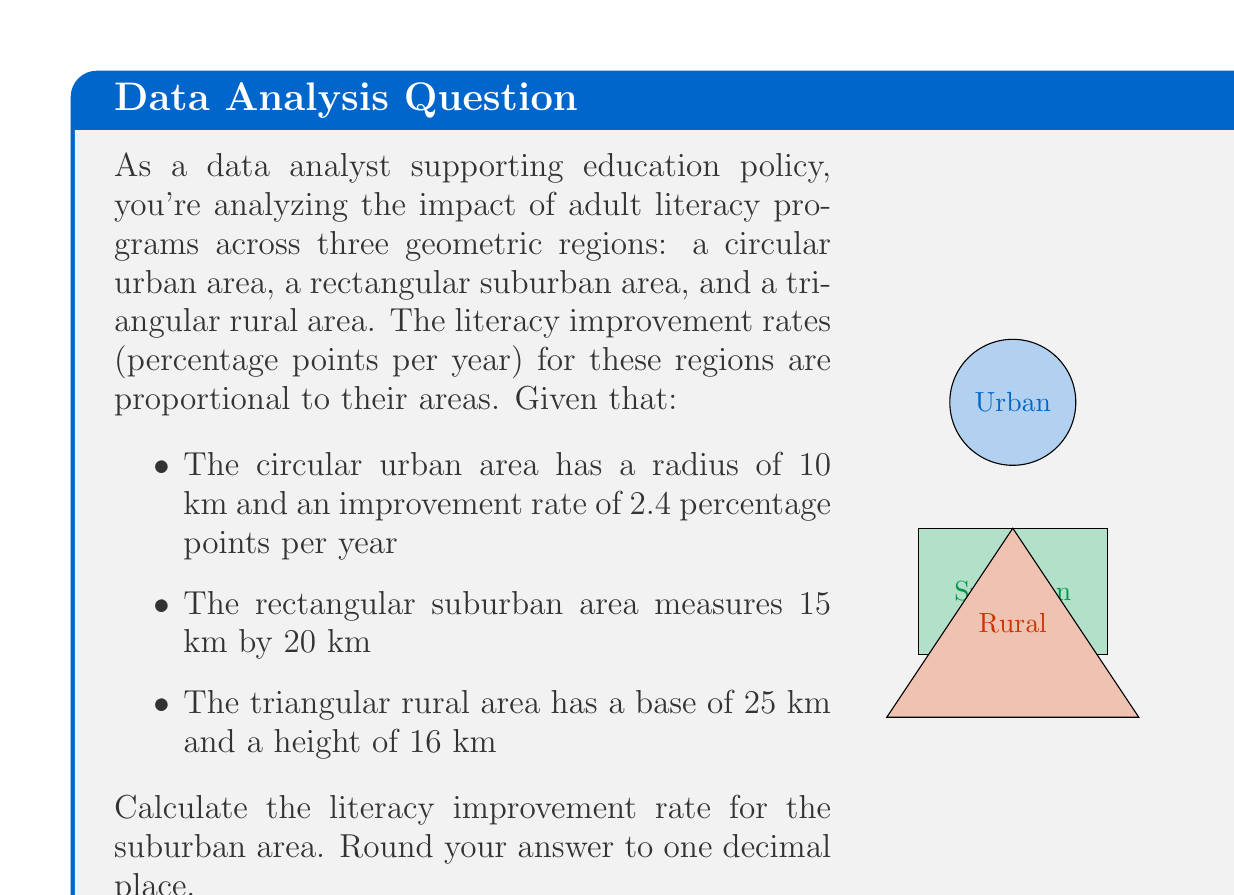Teach me how to tackle this problem. To solve this problem, we need to:
1. Calculate the areas of all three regions
2. Set up a proportion to find the improvement rate for the suburban area

Step 1: Calculate areas

Urban (circular) area:
$$ A_u = \pi r^2 = \pi \cdot 10^2 = 100\pi \approx 314.16 \text{ km}^2 $$

Suburban (rectangular) area:
$$ A_s = l \cdot w = 15 \cdot 20 = 300 \text{ km}^2 $$

Rural (triangular) area:
$$ A_r = \frac{1}{2} \cdot b \cdot h = \frac{1}{2} \cdot 25 \cdot 16 = 200 \text{ km}^2 $$

Step 2: Set up proportion

Let $x$ be the improvement rate for the suburban area. The proportion is:

$$ \frac{\text{Urban rate}}{\text{Urban area}} = \frac{\text{Suburban rate}}{\text{Suburban area}} $$

$$ \frac{2.4}{100\pi} = \frac{x}{300} $$

Step 3: Solve for $x$

$$ x = \frac{2.4 \cdot 300}{100\pi} \approx 2.291549 $$

Rounding to one decimal place: 2.3 percentage points per year.
Answer: 2.3 percentage points per year 